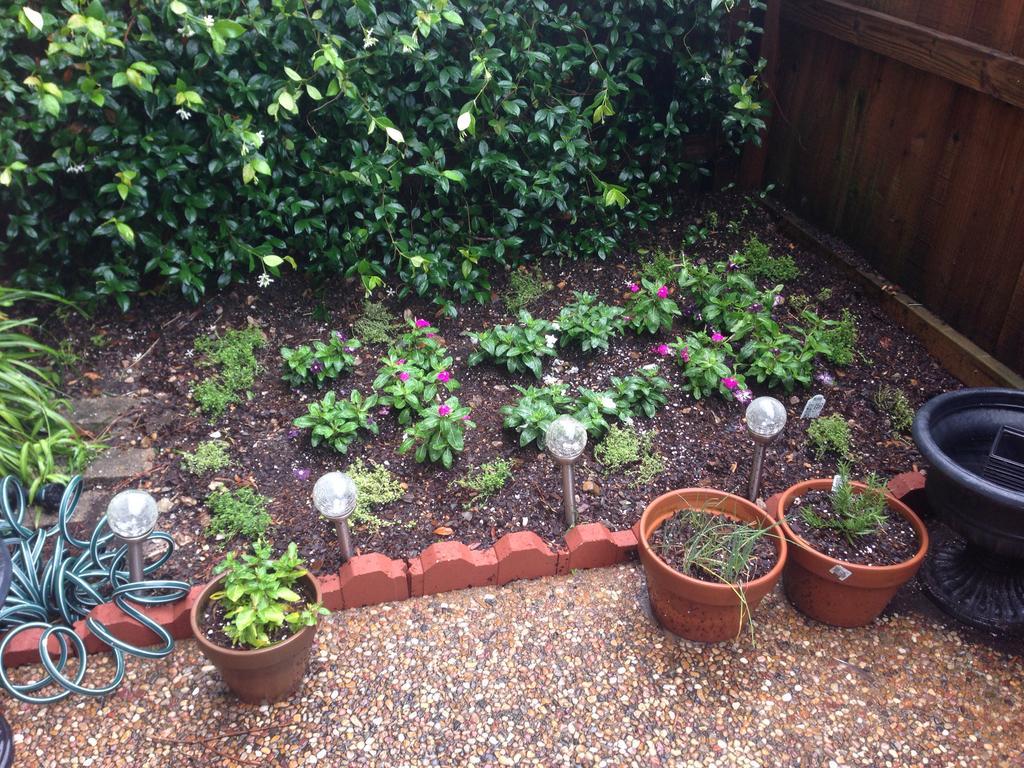In one or two sentences, can you explain what this image depicts? In this picture there are three plant pots and there is a black color object in the right corner and there is a water pipe in the left corner and there are few plants in the background and there is a wooden fence beside it. 